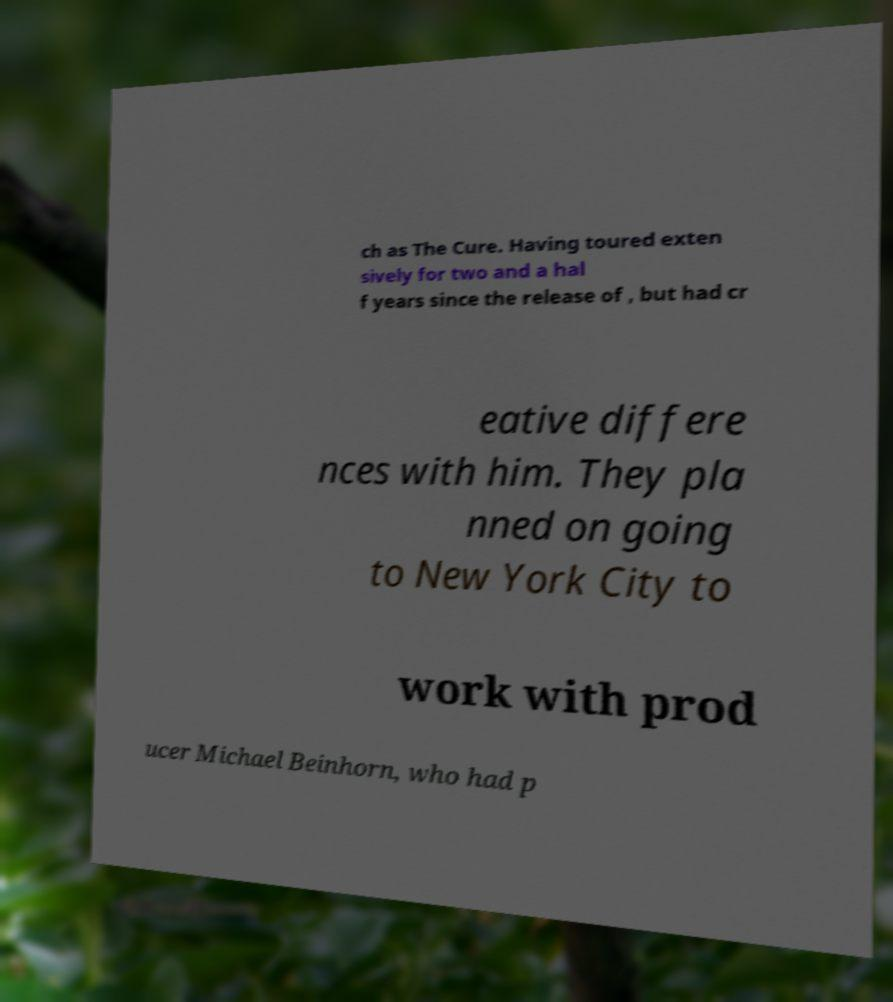I need the written content from this picture converted into text. Can you do that? ch as The Cure. Having toured exten sively for two and a hal f years since the release of , but had cr eative differe nces with him. They pla nned on going to New York City to work with prod ucer Michael Beinhorn, who had p 